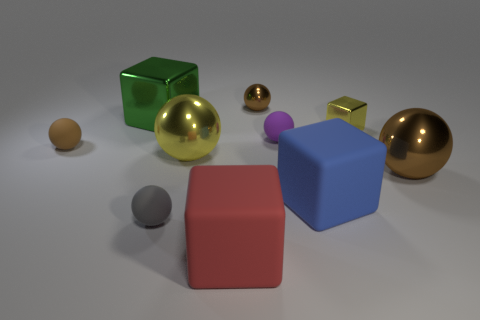Is the shape of the brown object on the left side of the big red cube the same as  the green thing?
Provide a short and direct response. No. What number of objects are either rubber blocks that are in front of the gray rubber sphere or things to the left of the red rubber block?
Give a very brief answer. 5. There is a large metal object that is the same shape as the blue rubber thing; what color is it?
Your response must be concise. Green. Are there any other things that have the same shape as the red thing?
Your answer should be very brief. Yes. There is a large blue matte object; is it the same shape as the small gray thing in front of the blue object?
Give a very brief answer. No. What is the gray sphere made of?
Your answer should be very brief. Rubber. What is the size of the gray thing that is the same shape as the brown matte thing?
Provide a succinct answer. Small. What number of other objects are the same material as the purple object?
Provide a succinct answer. 4. Is the tiny yellow thing made of the same material as the yellow thing left of the small brown shiny thing?
Ensure brevity in your answer.  Yes. Are there fewer big brown metal objects behind the large green metallic thing than tiny gray spheres that are behind the brown rubber sphere?
Your response must be concise. No. 